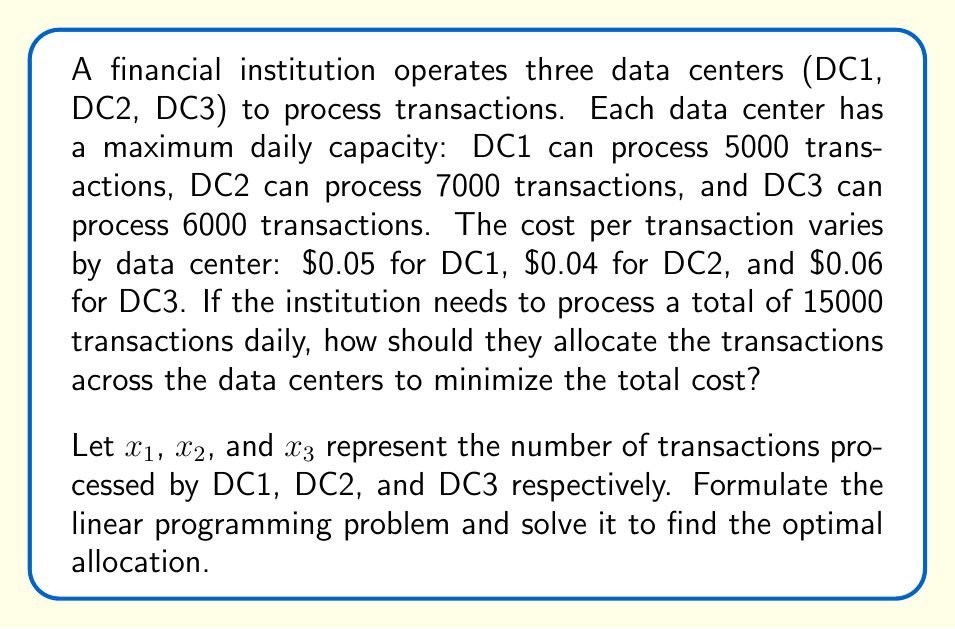Show me your answer to this math problem. To solve this linear programming problem, we'll follow these steps:

1. Formulate the objective function:
   Minimize total cost: $Z = 0.05x_1 + 0.04x_2 + 0.06x_3$

2. Define the constraints:
   a) Capacity constraints:
      $x_1 \leq 5000$ (DC1)
      $x_2 \leq 7000$ (DC2)
      $x_3 \leq 6000$ (DC3)
   b) Total transactions constraint:
      $x_1 + x_2 + x_3 = 15000$
   c) Non-negativity constraints:
      $x_1, x_2, x_3 \geq 0$

3. Solve using the simplex method or graphical method. In this case, we can use logical deduction:
   - DC2 has the lowest cost per transaction, so we should maximize its usage.
   - DC1 has the second-lowest cost, so we should use it next.
   - DC3 has the highest cost, so we should use it last.

4. Optimal allocation:
   - Assign 7000 transactions to DC2 (its maximum capacity)
   - Assign 5000 transactions to DC1 (its maximum capacity)
   - Assign the remaining 3000 transactions to DC3

5. Calculate the total cost:
   $Z = 0.05(5000) + 0.04(7000) + 0.06(3000)$
   $Z = 250 + 280 + 180 = 710$

Therefore, the optimal allocation is:
DC1: 5000 transactions
DC2: 7000 transactions
DC3: 3000 transactions
Total cost: $710
Answer: DC1: 5000, DC2: 7000, DC3: 3000; Total cost: $710 